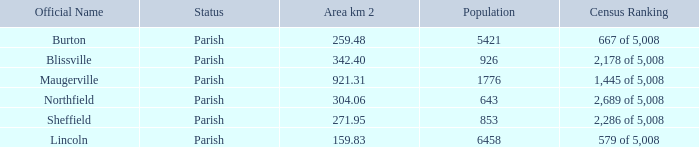What are the official name(s) of places with an area of 304.06 km2? Northfield. Write the full table. {'header': ['Official Name', 'Status', 'Area km 2', 'Population', 'Census Ranking'], 'rows': [['Burton', 'Parish', '259.48', '5421', '667 of 5,008'], ['Blissville', 'Parish', '342.40', '926', '2,178 of 5,008'], ['Maugerville', 'Parish', '921.31', '1776', '1,445 of 5,008'], ['Northfield', 'Parish', '304.06', '643', '2,689 of 5,008'], ['Sheffield', 'Parish', '271.95', '853', '2,286 of 5,008'], ['Lincoln', 'Parish', '159.83', '6458', '579 of 5,008']]} 